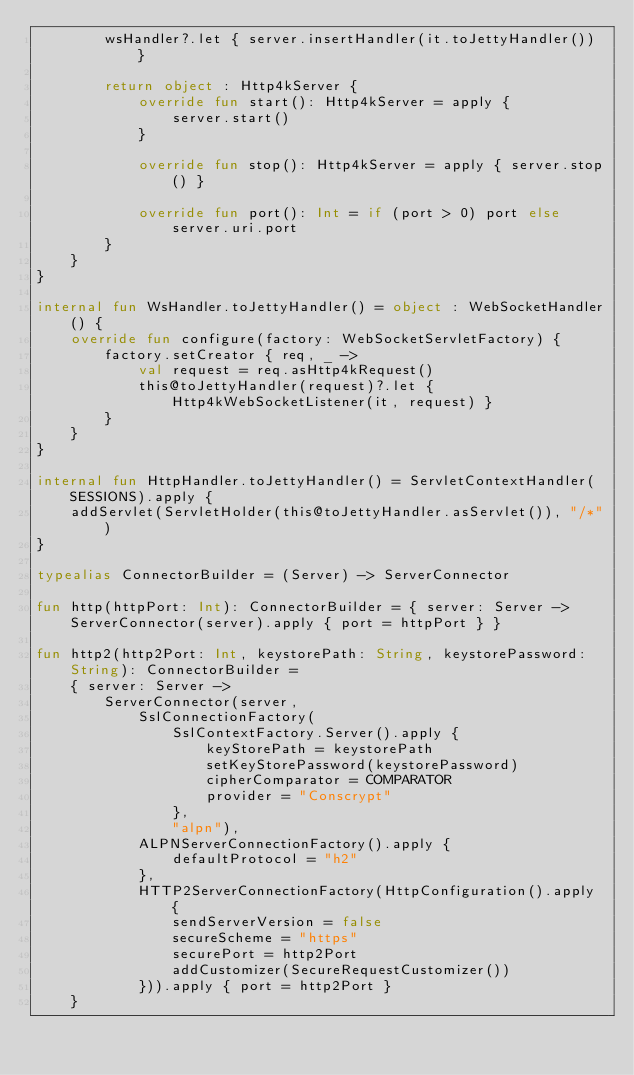<code> <loc_0><loc_0><loc_500><loc_500><_Kotlin_>        wsHandler?.let { server.insertHandler(it.toJettyHandler()) }

        return object : Http4kServer {
            override fun start(): Http4kServer = apply {
                server.start()
            }

            override fun stop(): Http4kServer = apply { server.stop() }

            override fun port(): Int = if (port > 0) port else server.uri.port
        }
    }
}

internal fun WsHandler.toJettyHandler() = object : WebSocketHandler() {
    override fun configure(factory: WebSocketServletFactory) {
        factory.setCreator { req, _ ->
            val request = req.asHttp4kRequest()
            this@toJettyHandler(request)?.let { Http4kWebSocketListener(it, request) }
        }
    }
}

internal fun HttpHandler.toJettyHandler() = ServletContextHandler(SESSIONS).apply {
    addServlet(ServletHolder(this@toJettyHandler.asServlet()), "/*")
}

typealias ConnectorBuilder = (Server) -> ServerConnector

fun http(httpPort: Int): ConnectorBuilder = { server: Server -> ServerConnector(server).apply { port = httpPort } }

fun http2(http2Port: Int, keystorePath: String, keystorePassword: String): ConnectorBuilder =
    { server: Server ->
        ServerConnector(server,
            SslConnectionFactory(
                SslContextFactory.Server().apply {
                    keyStorePath = keystorePath
                    setKeyStorePassword(keystorePassword)
                    cipherComparator = COMPARATOR
                    provider = "Conscrypt"
                },
                "alpn"),
            ALPNServerConnectionFactory().apply {
                defaultProtocol = "h2"
            },
            HTTP2ServerConnectionFactory(HttpConfiguration().apply {
                sendServerVersion = false
                secureScheme = "https"
                securePort = http2Port
                addCustomizer(SecureRequestCustomizer())
            })).apply { port = http2Port }
    }</code> 